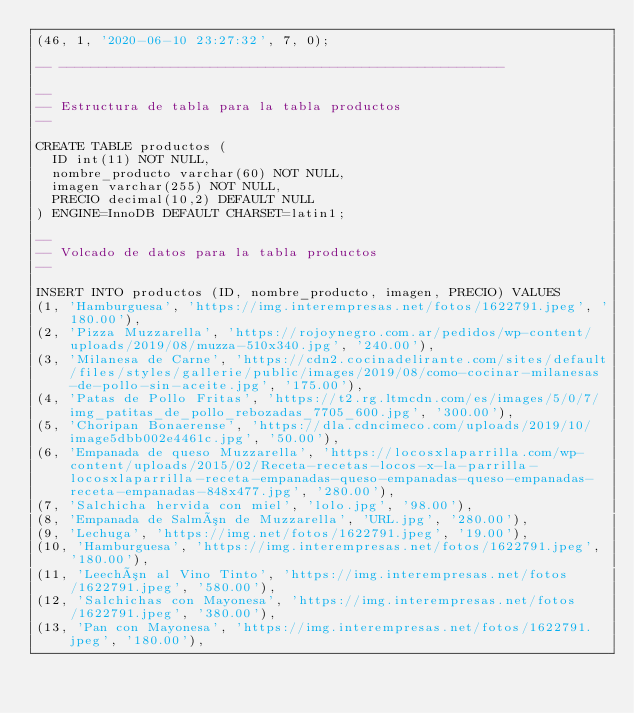<code> <loc_0><loc_0><loc_500><loc_500><_SQL_>(46, 1, '2020-06-10 23:27:32', 7, 0);

-- --------------------------------------------------------

--
-- Estructura de tabla para la tabla productos
--

CREATE TABLE productos (
  ID int(11) NOT NULL,
  nombre_producto varchar(60) NOT NULL,
  imagen varchar(255) NOT NULL,
  PRECIO decimal(10,2) DEFAULT NULL
) ENGINE=InnoDB DEFAULT CHARSET=latin1;

--
-- Volcado de datos para la tabla productos
--

INSERT INTO productos (ID, nombre_producto, imagen, PRECIO) VALUES
(1, 'Hamburguesa', 'https://img.interempresas.net/fotos/1622791.jpeg', '180.00'),
(2, 'Pizza Muzzarella', 'https://rojoynegro.com.ar/pedidos/wp-content/uploads/2019/08/muzza-510x340.jpg', '240.00'),
(3, 'Milanesa de Carne', 'https://cdn2.cocinadelirante.com/sites/default/files/styles/gallerie/public/images/2019/08/como-cocinar-milanesas-de-pollo-sin-aceite.jpg', '175.00'),
(4, 'Patas de Pollo Fritas', 'https://t2.rg.ltmcdn.com/es/images/5/0/7/img_patitas_de_pollo_rebozadas_7705_600.jpg', '300.00'),
(5, 'Choripan Bonaerense', 'https://dla.cdncimeco.com/uploads/2019/10/image5dbb002e4461c.jpg', '50.00'),
(6, 'Empanada de queso Muzzarella', 'https://locosxlaparrilla.com/wp-content/uploads/2015/02/Receta-recetas-locos-x-la-parrilla-locosxlaparrilla-receta-empanadas-queso-empanadas-queso-empanadas-receta-empanadas-848x477.jpg', '280.00'),
(7, 'Salchicha hervida con miel', 'lolo.jpg', '98.00'),
(8, 'Empanada de Salmón de Muzzarella', 'URL.jpg', '280.00'),
(9, 'Lechuga', 'https://img.net/fotos/1622791.jpeg', '19.00'),
(10, 'Hamburguesa', 'https://img.interempresas.net/fotos/1622791.jpeg', '180.00'),
(11, 'Leechón al Vino Tinto', 'https://img.interempresas.net/fotos/1622791.jpeg', '580.00'),
(12, 'Salchichas con Mayonesa', 'https://img.interempresas.net/fotos/1622791.jpeg', '380.00'),
(13, 'Pan con Mayonesa', 'https://img.interempresas.net/fotos/1622791.jpeg', '180.00'),</code> 